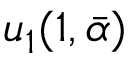<formula> <loc_0><loc_0><loc_500><loc_500>u _ { 1 } ( 1 , \bar { \alpha } )</formula> 